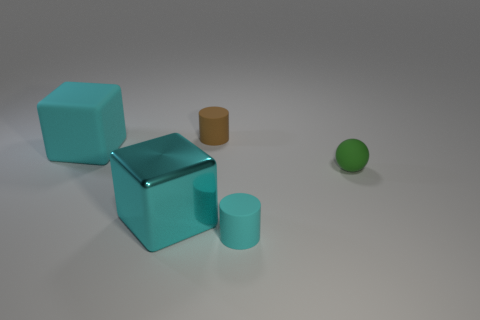There is a matte cylinder that is on the right side of the small cylinder that is behind the small cyan cylinder; are there any tiny rubber spheres on the right side of it?
Keep it short and to the point. Yes. What color is the large thing that is the same material as the green sphere?
Provide a short and direct response. Cyan. How many small things are the same material as the small cyan cylinder?
Provide a short and direct response. 2. Do the tiny cyan thing and the big cyan cube behind the large cyan metallic thing have the same material?
Keep it short and to the point. Yes. How many objects are things that are on the left side of the tiny brown thing or small green objects?
Provide a succinct answer. 3. There is a cyan matte thing to the left of the tiny rubber cylinder that is behind the cylinder to the right of the small brown matte cylinder; what size is it?
Provide a short and direct response. Large. What is the material of the large thing that is the same color as the big metal block?
Keep it short and to the point. Rubber. Are there any other things that are the same shape as the small green matte object?
Give a very brief answer. No. There is a matte cylinder that is in front of the small matte sphere that is in front of the big cyan rubber object; what size is it?
Ensure brevity in your answer.  Small. What number of large objects are rubber blocks or metal things?
Offer a terse response. 2. 